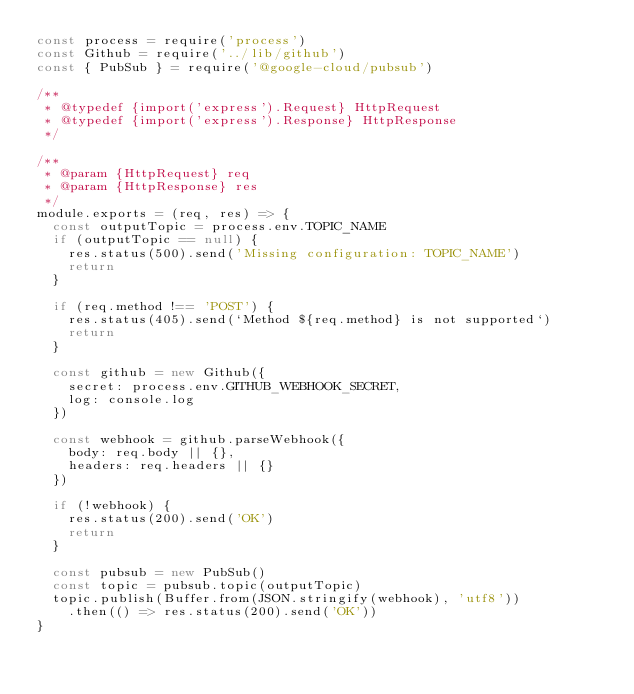Convert code to text. <code><loc_0><loc_0><loc_500><loc_500><_JavaScript_>const process = require('process')
const Github = require('../lib/github')
const { PubSub } = require('@google-cloud/pubsub')

/**
 * @typedef {import('express').Request} HttpRequest
 * @typedef {import('express').Response} HttpResponse
 */

/**
 * @param {HttpRequest} req
 * @param {HttpResponse} res
 */
module.exports = (req, res) => {
  const outputTopic = process.env.TOPIC_NAME
  if (outputTopic == null) {
    res.status(500).send('Missing configuration: TOPIC_NAME')
    return
  }

  if (req.method !== 'POST') {
    res.status(405).send(`Method ${req.method} is not supported`)
    return
  }

  const github = new Github({
    secret: process.env.GITHUB_WEBHOOK_SECRET,
    log: console.log
  })

  const webhook = github.parseWebhook({
    body: req.body || {},
    headers: req.headers || {}
  })

  if (!webhook) {
    res.status(200).send('OK')
    return
  }

  const pubsub = new PubSub()
  const topic = pubsub.topic(outputTopic)
  topic.publish(Buffer.from(JSON.stringify(webhook), 'utf8'))
    .then(() => res.status(200).send('OK'))
}
</code> 